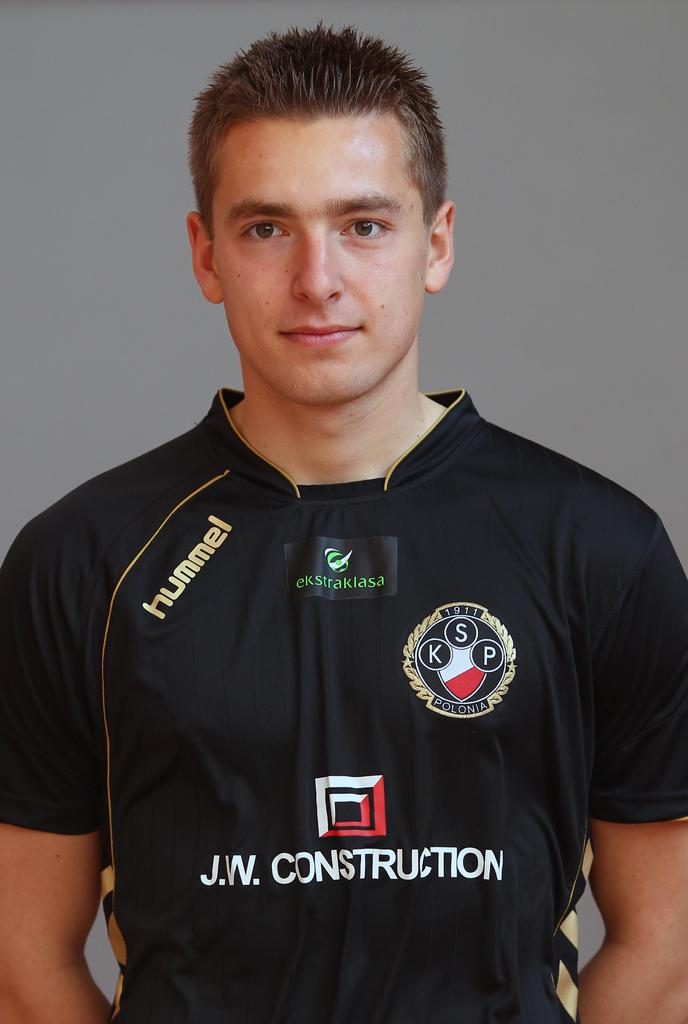<image>
Share a concise interpretation of the image provided. Man wearing a soccer jersey that says "J.W. Construction" on the front. 